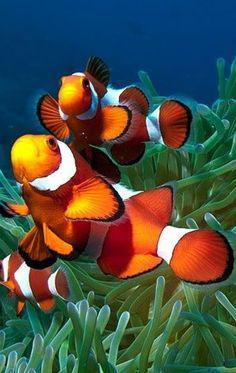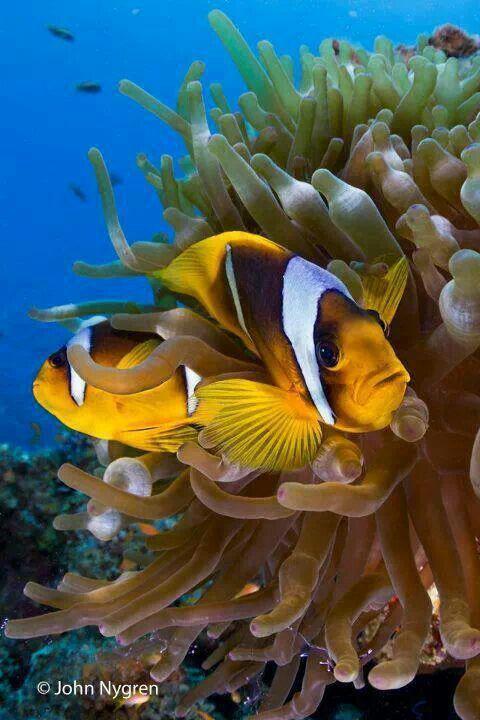The first image is the image on the left, the second image is the image on the right. Given the left and right images, does the statement "There is exactly one clown fish." hold true? Answer yes or no. No. The first image is the image on the left, the second image is the image on the right. Analyze the images presented: Is the assertion "Each image shows at least two brightly colored striped fish of the same variety swimming in a scene that contains anemone tendrils." valid? Answer yes or no. Yes. 